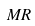Convert formula to latex. <formula><loc_0><loc_0><loc_500><loc_500>M R</formula> 